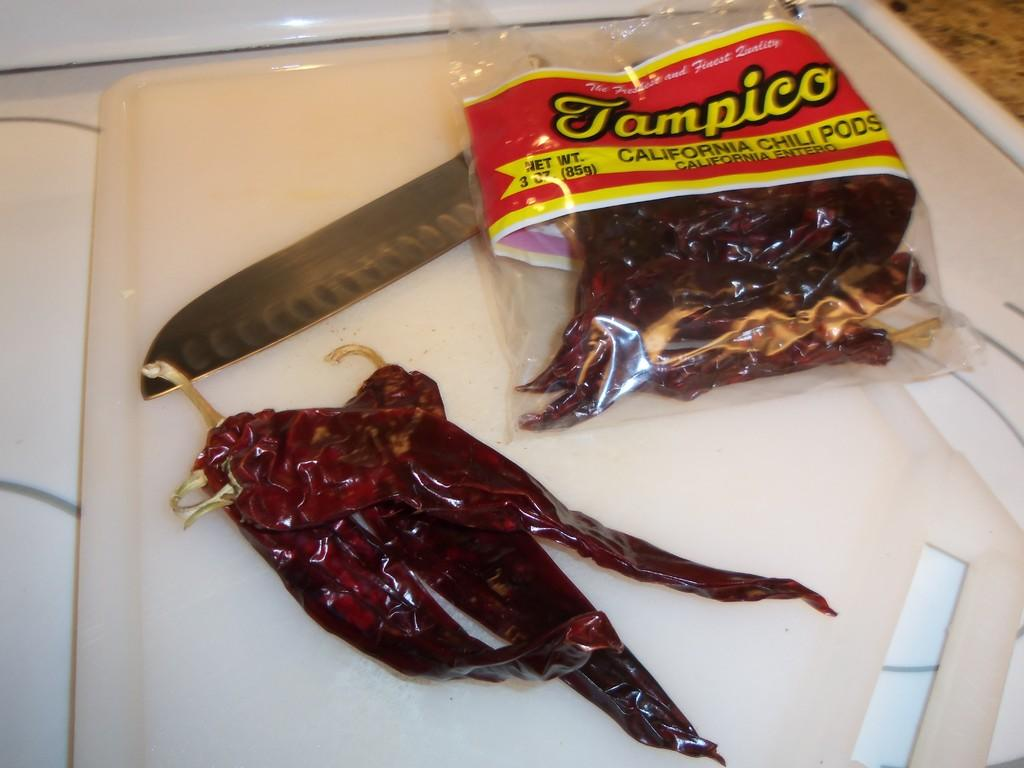What is the main object on which other items are placed in the image? There is a tray in the image, and all other objects are on it. What type of food items can be seen in the image? There are red chillies in the image. What utensil is present in the image? There is a knife in the image. Is there any covering for the objects in the image? Yes, there is a cover in the image. How many sticks are used to stitch the cover in the image? There are no sticks or stitching present in the image; it only shows a tray with red chillies, a knife, and a cover. 